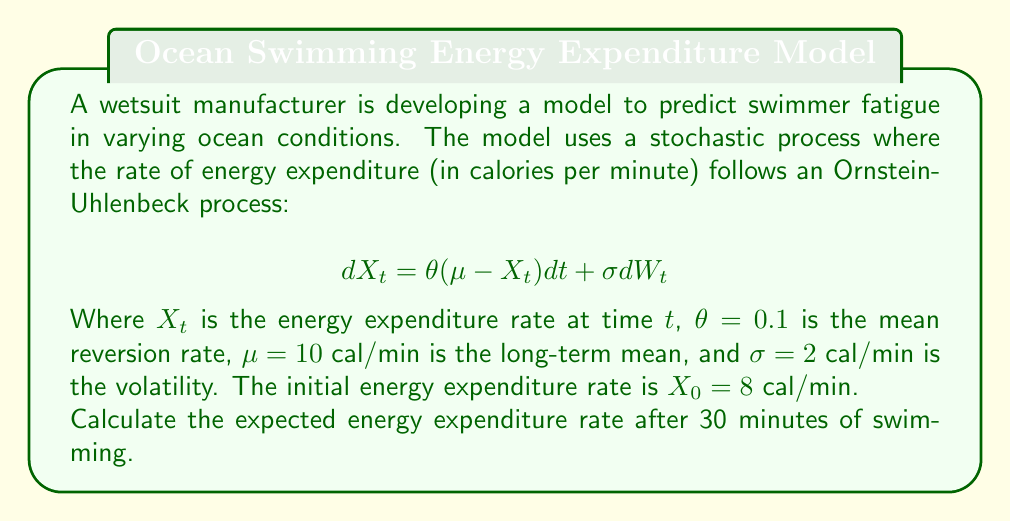Could you help me with this problem? To solve this problem, we need to use the properties of the Ornstein-Uhlenbeck process. The expected value of an Ornstein-Uhlenbeck process at time $t$, given an initial value $X_0$, is:

$$E[X_t | X_0] = \mu + (X_0 - \mu)e^{-\theta t}$$

Let's break down the solution step-by-step:

1) We are given:
   $\theta = 0.1$
   $\mu = 10$ cal/min
   $X_0 = 8$ cal/min
   $t = 30$ minutes

2) Substitute these values into the formula:

   $$E[X_{30} | X_0] = 10 + (8 - 10)e^{-0.1 \cdot 30}$$

3) Simplify the expression inside the parentheses:
   
   $$E[X_{30} | X_0] = 10 + (-2)e^{-3}$$

4) Calculate $e^{-3}$:
   
   $$e^{-3} \approx 0.0498$$

5) Multiply:
   
   $$E[X_{30} | X_0] = 10 + (-2 \cdot 0.0498)$$

6) Simplify:
   
   $$E[X_{30} | X_0] = 10 - 0.0996$$

7) Calculate the final result:
   
   $$E[X_{30} | X_0] \approx 9.9004$$ cal/min

Therefore, the expected energy expenditure rate after 30 minutes of swimming is approximately 9.9004 cal/min.
Answer: 9.9004 cal/min 